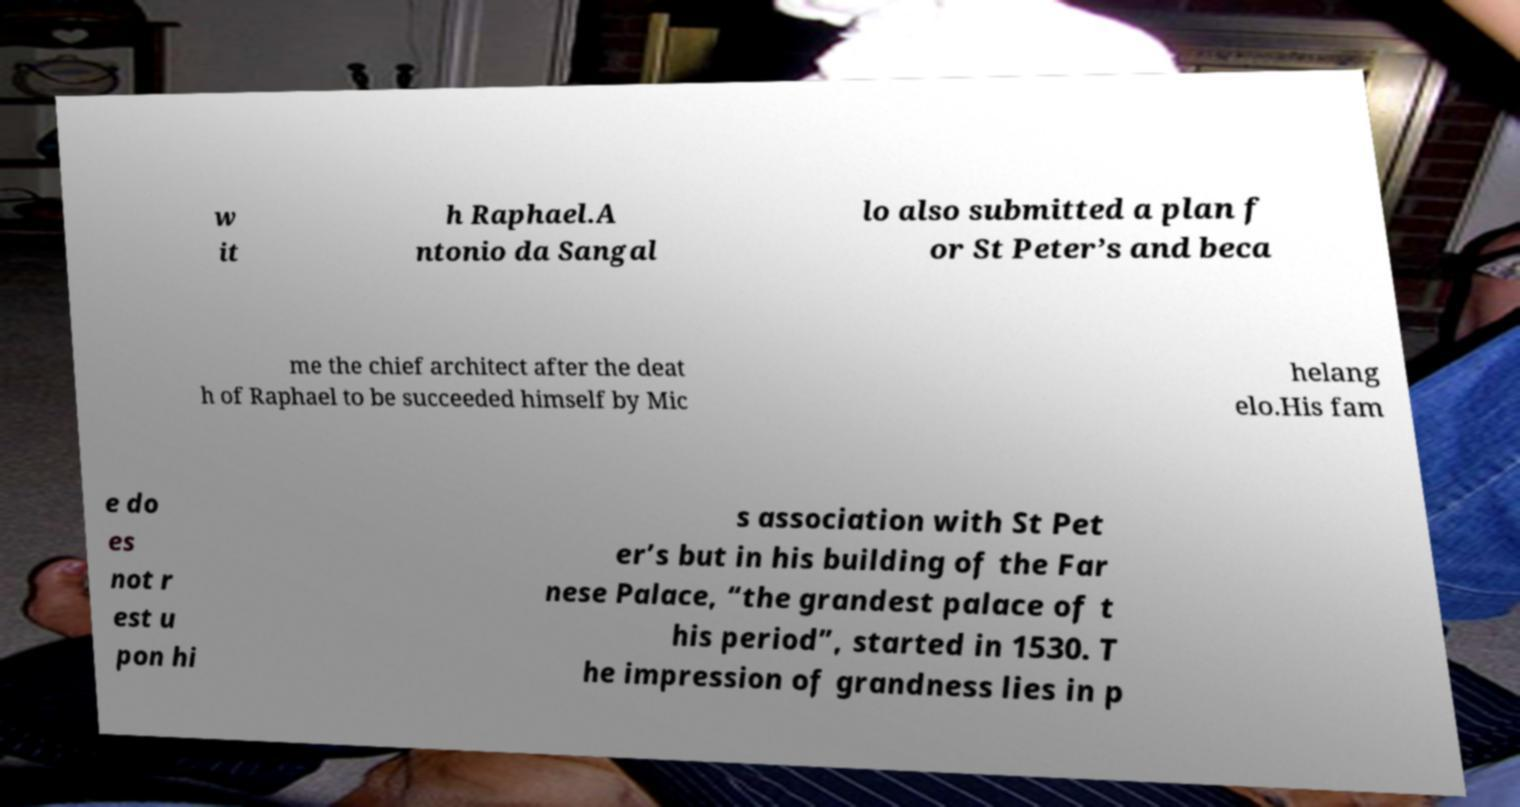Could you extract and type out the text from this image? w it h Raphael.A ntonio da Sangal lo also submitted a plan f or St Peter’s and beca me the chief architect after the deat h of Raphael to be succeeded himself by Mic helang elo.His fam e do es not r est u pon hi s association with St Pet er’s but in his building of the Far nese Palace, “the grandest palace of t his period”, started in 1530. T he impression of grandness lies in p 